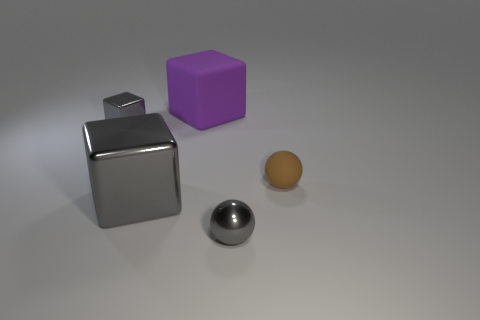Subtract all gray blocks. How many blocks are left? 1 Add 1 matte spheres. How many objects exist? 6 Subtract all blue spheres. How many blue blocks are left? 0 Add 3 large gray metallic blocks. How many large gray metallic blocks exist? 4 Subtract all purple cubes. How many cubes are left? 2 Subtract 0 yellow spheres. How many objects are left? 5 Subtract all spheres. How many objects are left? 3 Subtract 1 balls. How many balls are left? 1 Subtract all cyan blocks. Subtract all purple cylinders. How many blocks are left? 3 Subtract all large purple matte blocks. Subtract all small metallic objects. How many objects are left? 2 